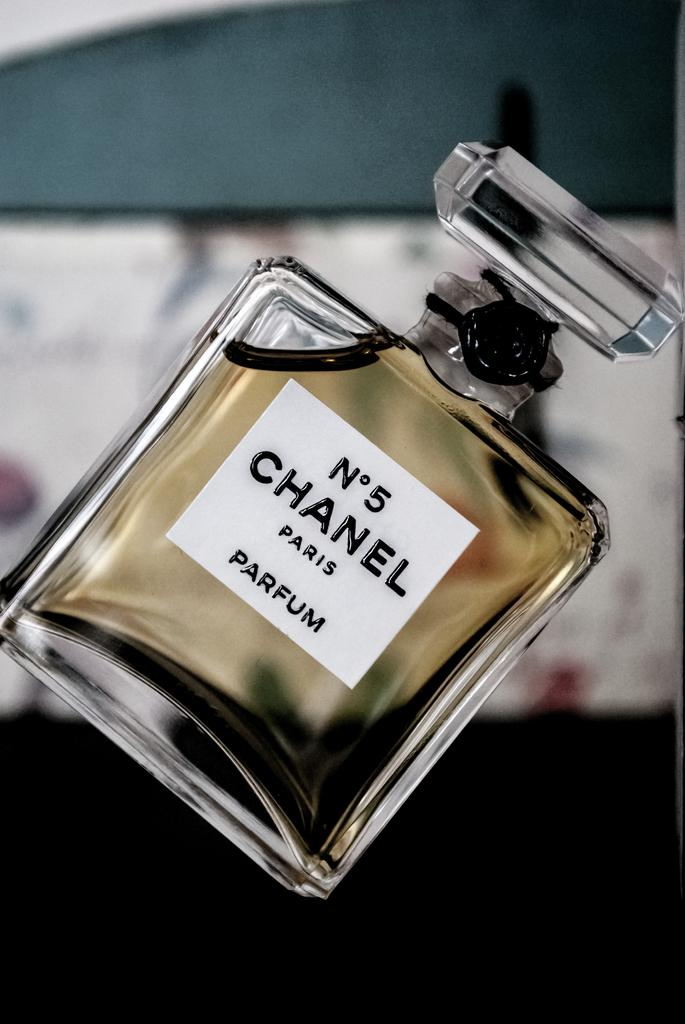<image>
Give a short and clear explanation of the subsequent image. Chanel number 5 perfume from Paris is placed diagnolly. 